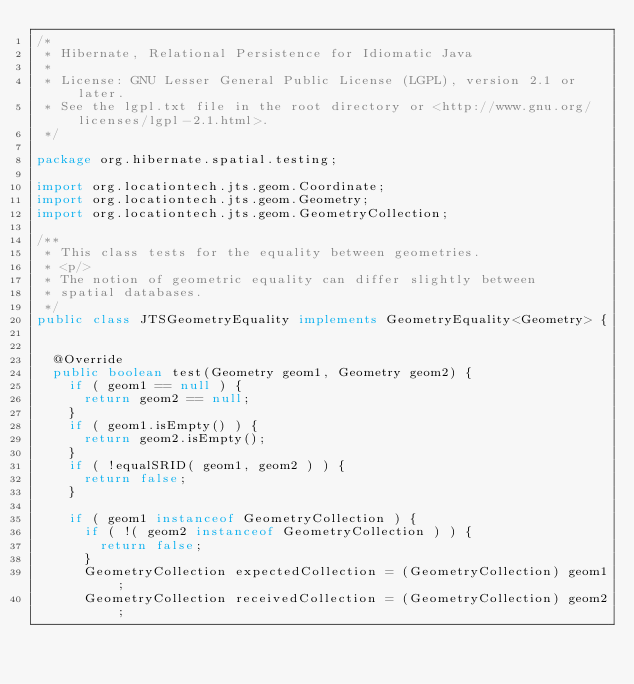<code> <loc_0><loc_0><loc_500><loc_500><_Java_>/*
 * Hibernate, Relational Persistence for Idiomatic Java
 *
 * License: GNU Lesser General Public License (LGPL), version 2.1 or later.
 * See the lgpl.txt file in the root directory or <http://www.gnu.org/licenses/lgpl-2.1.html>.
 */

package org.hibernate.spatial.testing;

import org.locationtech.jts.geom.Coordinate;
import org.locationtech.jts.geom.Geometry;
import org.locationtech.jts.geom.GeometryCollection;

/**
 * This class tests for the equality between geometries.
 * <p/>
 * The notion of geometric equality can differ slightly between
 * spatial databases.
 */
public class JTSGeometryEquality implements GeometryEquality<Geometry> {


	@Override
	public boolean test(Geometry geom1, Geometry geom2) {
		if ( geom1 == null ) {
			return geom2 == null;
		}
		if ( geom1.isEmpty() ) {
			return geom2.isEmpty();
		}
		if ( !equalSRID( geom1, geom2 ) ) {
			return false;
		}

		if ( geom1 instanceof GeometryCollection ) {
			if ( !( geom2 instanceof GeometryCollection ) ) {
				return false;
			}
			GeometryCollection expectedCollection = (GeometryCollection) geom1;
			GeometryCollection receivedCollection = (GeometryCollection) geom2;</code> 